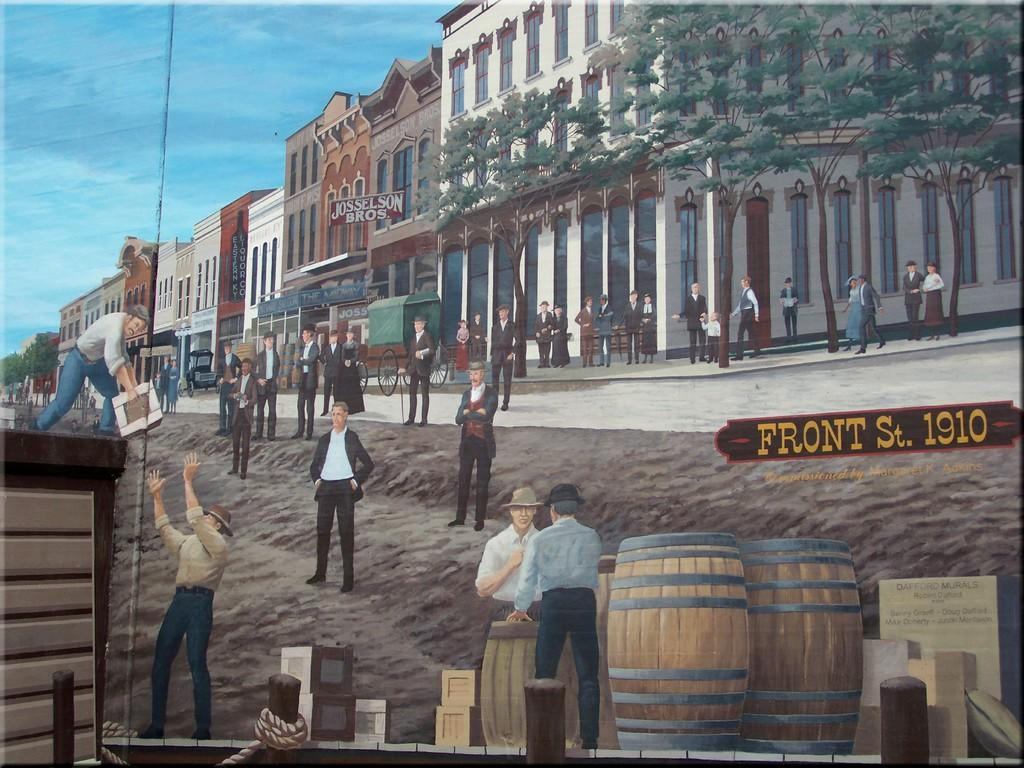Provide a one-sentence caption for the provided image. An artist's drawing of Front Street as it appeared in 1910. 